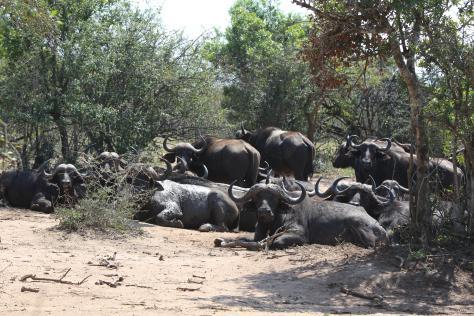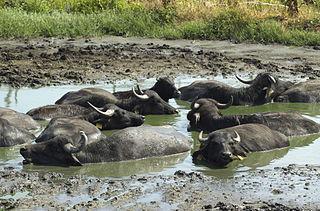The first image is the image on the left, the second image is the image on the right. Given the left and right images, does the statement "Several water buffalos are standing in water in one of the images." hold true? Answer yes or no. Yes. The first image is the image on the left, the second image is the image on the right. For the images shown, is this caption "The left image shows a fog-like cloud above a herd of dark hooved animals moving en masse." true? Answer yes or no. No. 